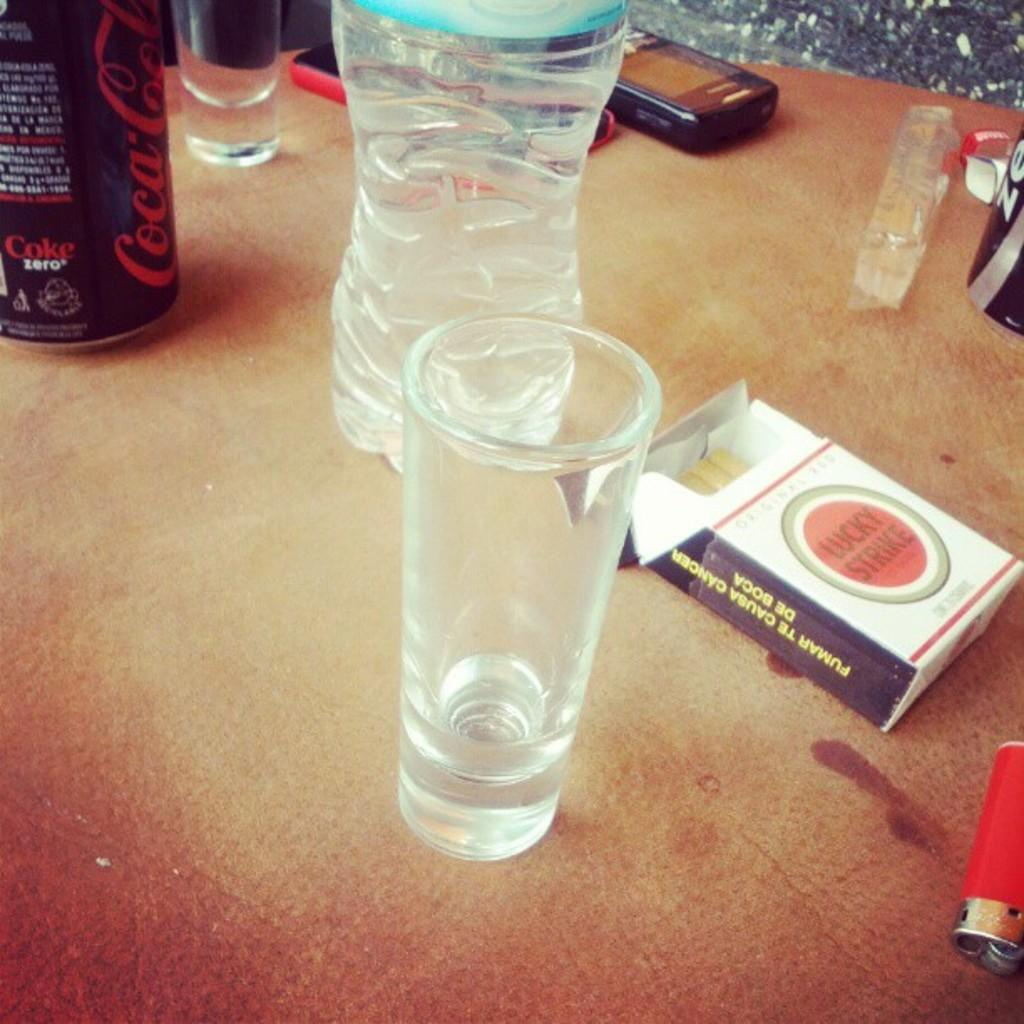<image>
Write a terse but informative summary of the picture. A table with glasses, a water bottle, a cigarette case, and a CocaCola can. 